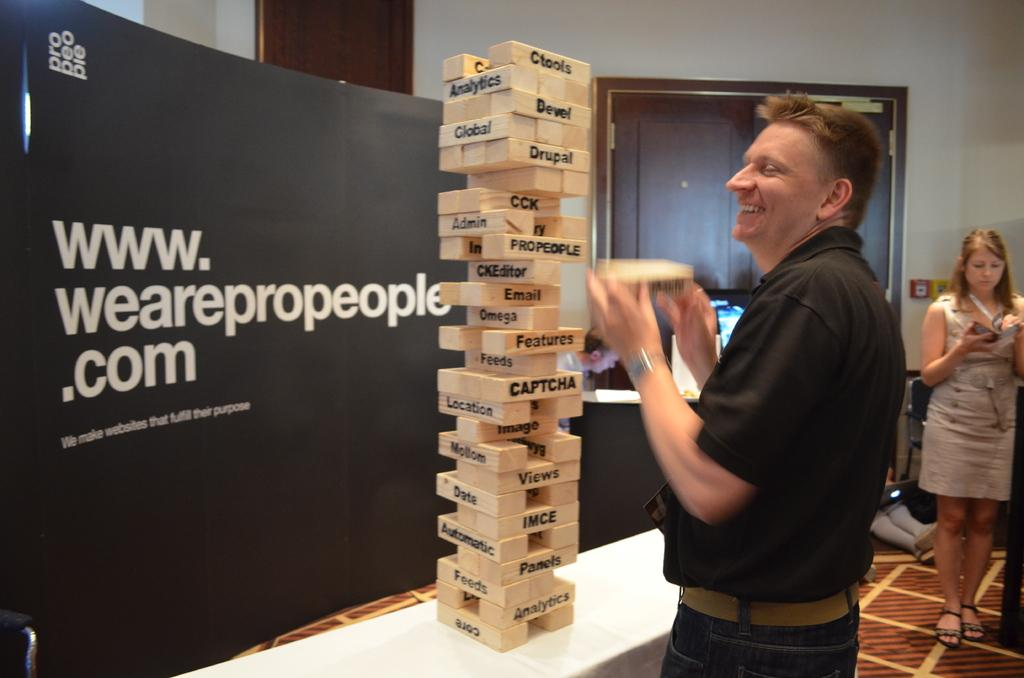<image>
Provide a brief description of the given image. A man is playing a giant game of Jenga while standing in front of a www.wearepropeople.com advertisement. 